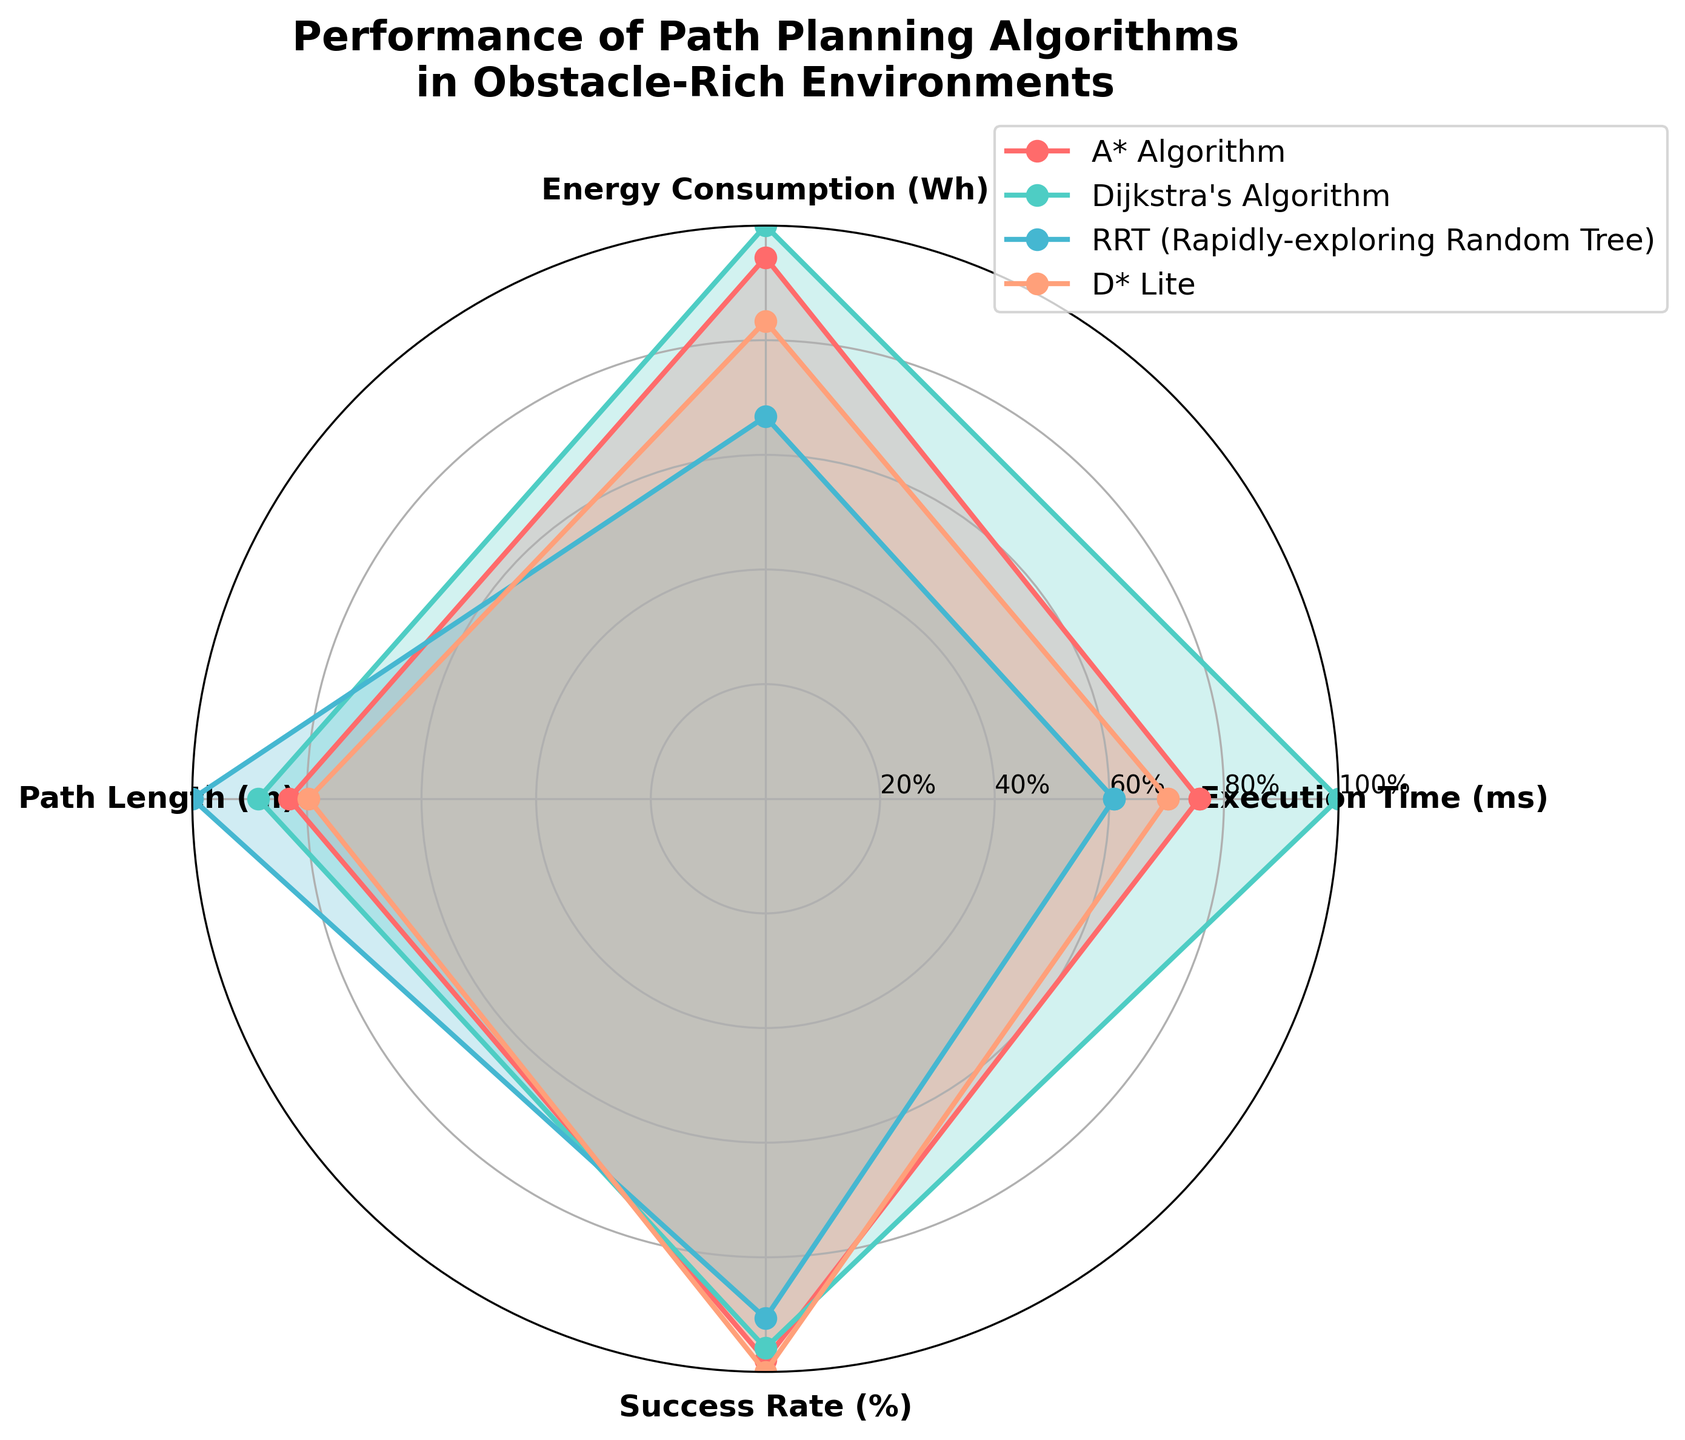What is the title of the radar chart? The title is located at the top of the radar chart in bold font, helping identify the chart's subject.
Answer: Performance of Path Planning Algorithms in Obstacle-Rich Environments Which algorithm has the lowest execution time? Compare the values for "Execution Time (ms)" along the related axis for each algorithm.
Answer: RRT (Rapidly-exploring Random Tree) How does Dijkstra's Algorithm compare in Success Rate (%) to D* Lite? Check the corresponding axis for "Success Rate (%)" and compare the plotted values for both algorithms.
Answer: Dijkstra's Algorithm has a lower Success Rate (%) than D* Lite Which algorithms have a Path Length (m) value above 14? Look at the "Path Length (m)" axis and identify values above 14, then find the corresponding algorithms.
Answer: RRT (Rapidly-exploring Random Tree) Arrange the algorithms in ascending order of Energy Consumption (Wh). Compare the values plotted along the "Energy Consumption (Wh)" axis and list the algorithms from the lowest to the highest.
Answer: RRT < D* Lite < A* Algorithm < Dijkstra's Algorithm Which algorithm has the highest combined score when evaluating Execution Time (ms), Energy Consumption (Wh), Path Length (m), and Success Rate (%)? Normalize each attribute and sum up the scores for each algorithm. The one with the highest total is the answer.
Answer: D* Lite How does the average execution time of A* Algorithm and Dijkstra's Algorithm compare to that of D* Lite and RRT? Calculate the average Execution Time (ms) for A* Algorithm and Dijkstra's Algorithm, then compare it to the average of D* Lite and RRT.
Answer: (65)ms for A* + Dijkstra's vs (48.5)ms for D* Lite + RRT What percentage difference is there in the Success Rate (%) between the highest and the lowest algorithms? Identify the highest and lowest Success Rate (%) values, calculate the percentage difference: (Highest - Lowest) / Highest * 100.
Answer: (96-87)/96*100 ≈ 9.38% For which attribute is Dijkstra's Algorithm performing better than both D* Lite and RRT? Compare the values for Dijkstra's Algorithm against D* Lite and RRT for each attribute.
Answer: Path Length (m) What is the average Success Rate (%) for all algorithms? Sum the Success Rate (%) values and divide by the number of algorithms.
Answer: (94+92+87+96)/4 = 92.25% 